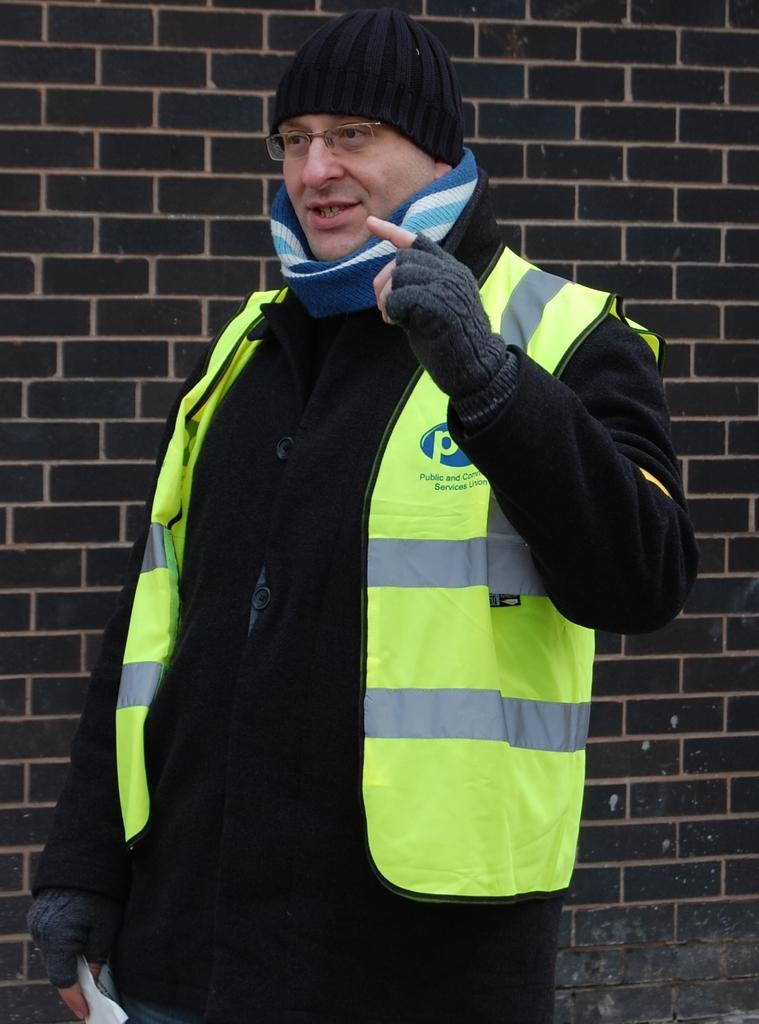What is the main subject of the image? The main subject of the image is a man. Can you describe the man's appearance in the image? The man is wearing spectacles, a cap, a radium jacket, and hand gloves. What can be seen in the background of the image? There is a wall in the background of the image. What type of zinc is the man using to protect himself from the winter weather in the image? There is no zinc or reference to winter weather present in the image. The man is wearing a radium jacket, but it is not mentioned as a protection against winter weather. 